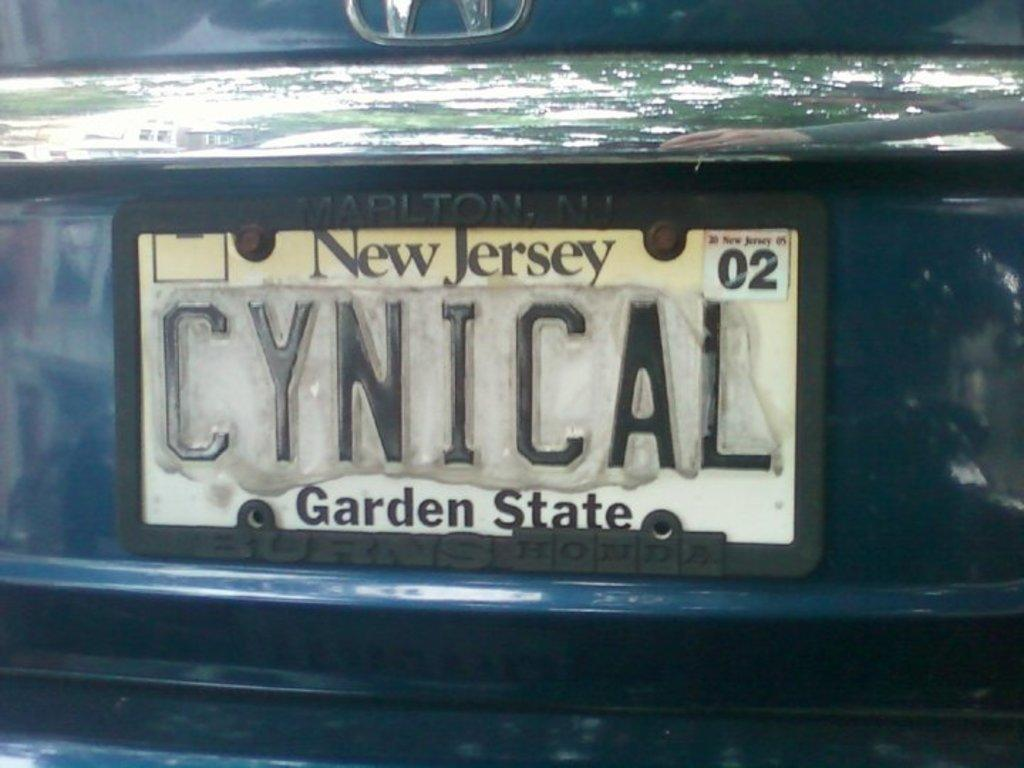<image>
Relay a brief, clear account of the picture shown. New Jersey license plate that says CYNICAL in the back. 